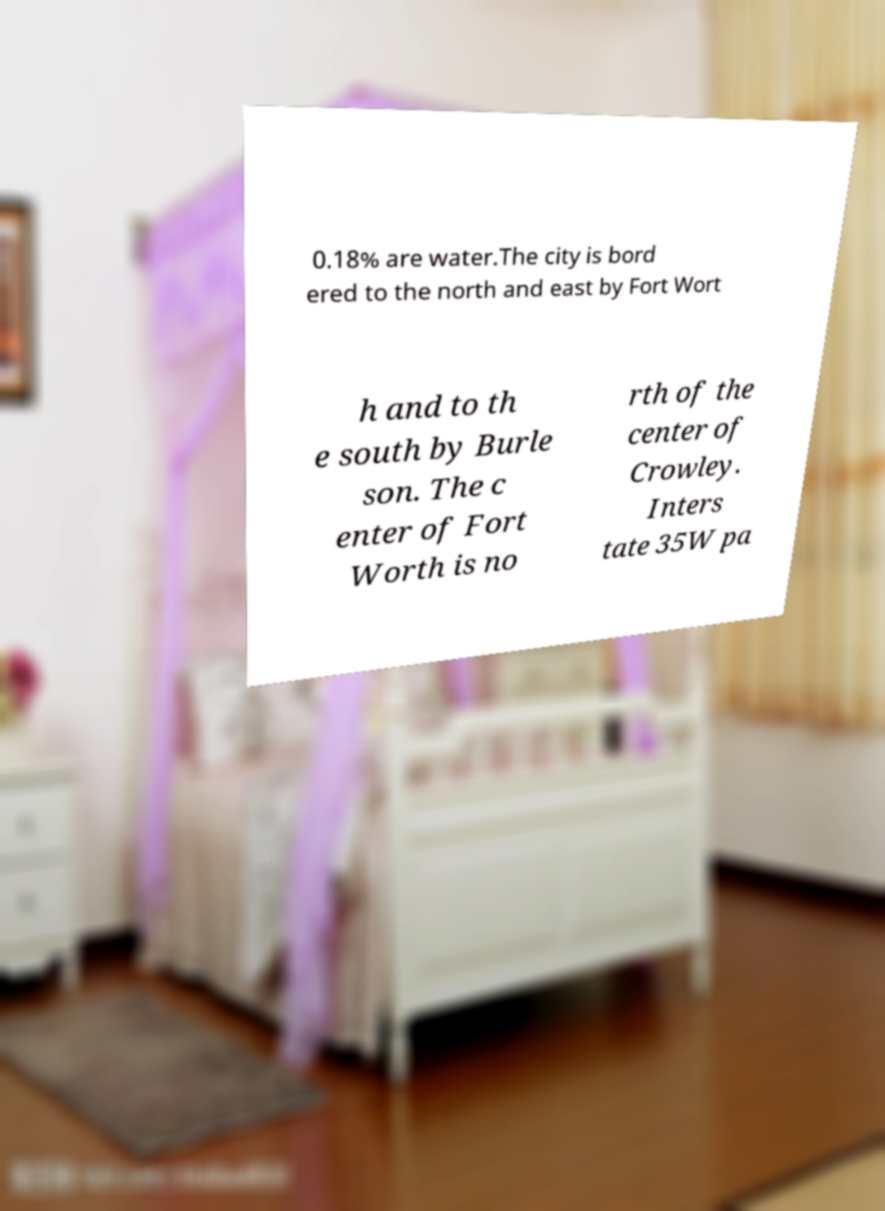There's text embedded in this image that I need extracted. Can you transcribe it verbatim? 0.18% are water.The city is bord ered to the north and east by Fort Wort h and to th e south by Burle son. The c enter of Fort Worth is no rth of the center of Crowley. Inters tate 35W pa 